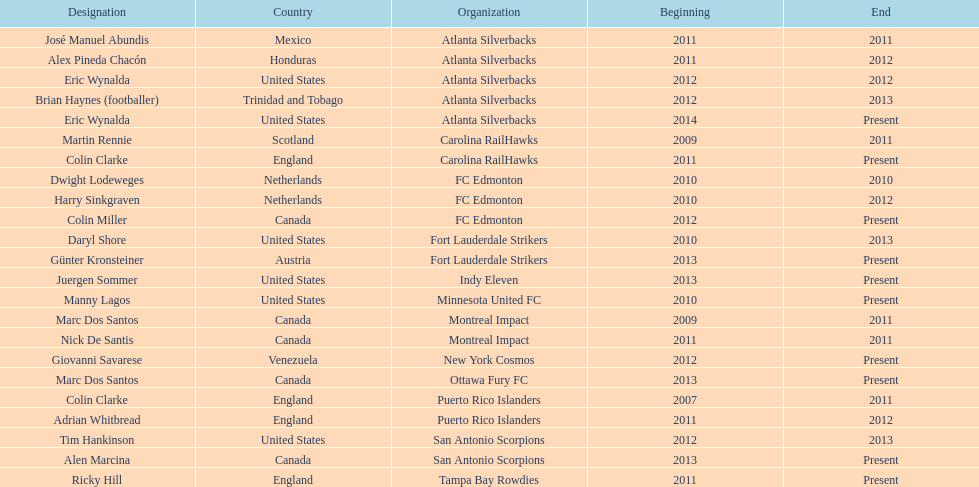Who was the coach of fc edmonton before miller? Harry Sinkgraven. 